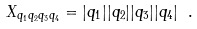<formula> <loc_0><loc_0><loc_500><loc_500>X _ { q _ { 1 } q _ { 2 } q _ { 3 } q _ { 4 } } = | q _ { 1 } | | q _ { 2 } | | q _ { 3 } | | q _ { 4 } | \ .</formula> 